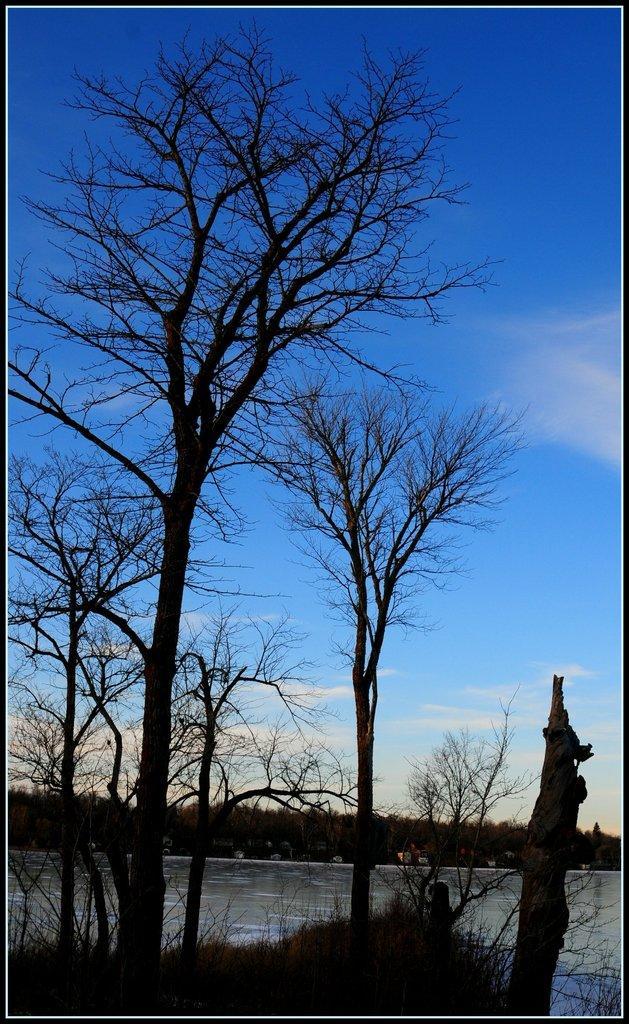In one or two sentences, can you explain what this image depicts? In the picture I can see grass, dry trees, water and the blue color sky with clouds in the background. 